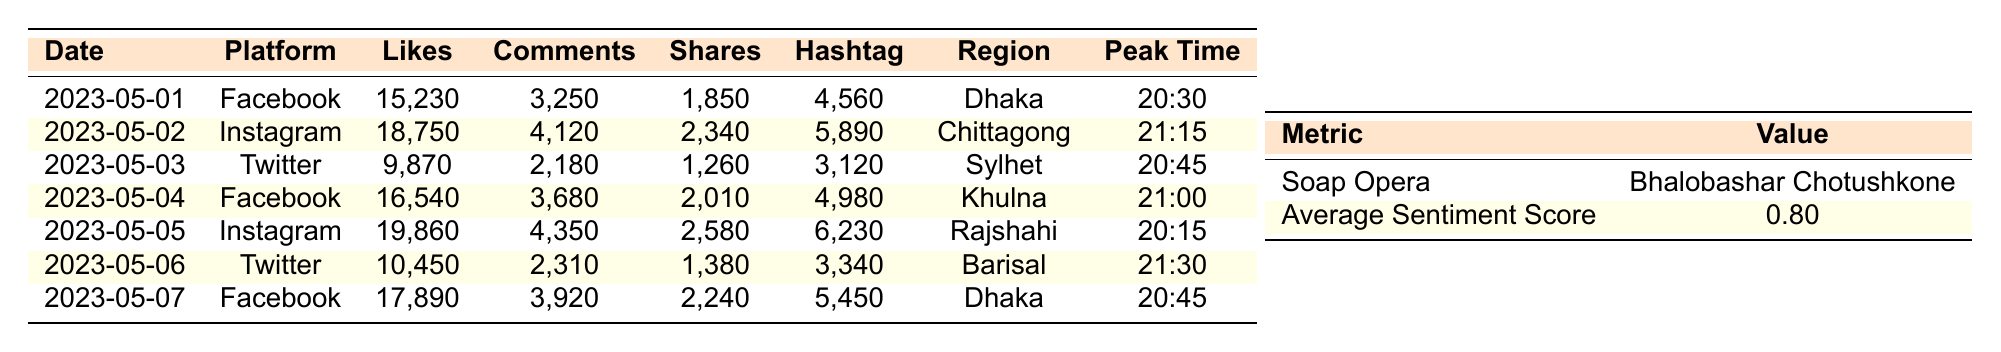What is the average number of likes across all platforms for the soap opera? To find the average number of likes, we need to sum the likes for each day and divide by the number of days. The likes are 15230, 18750, 9870, 16540, 19860, 10450, 17890. Total likes = 15230 + 18750 + 9870 + 16540 + 19860 + 10450 + 17890 = 113,570. There are 7 days, so the average is 113,570 / 7 = 16,224.29, which rounds to 16,224.
Answer: 16,224 Which platform had the highest number of comments on a single day? Looking at the comments for each platform and date, the highest number is on May 05 with 4,350 comments on Instagram.
Answer: Instagram on May 05 What was the most active region on May 02? The table indicates that on May 02, the most active region was Chittagong. This is directly stated in the table entry for that date.
Answer: Chittagong Is the sentiment score higher for Facebook or Instagram on May 05? On May 05, Facebook has a sentiment score of 0.81, while Instagram has a sentiment score of 0.85. Since 0.85 is greater than 0.81, we conclude that the sentiment score is higher for Instagram.
Answer: Instagram What is the total number of shares across all platforms for the soap opera? We need to sum the shares for each day: 1850 + 2340 + 1260 + 2010 + 2580 + 1380 + 2240 = 12,620.
Answer: 12,620 Did any platform consistently have the highest engagement in terms of likes over the week? After checking each date's likes, Instagram has the highest likes on May 02 and May 05, Facebook had higher likes on May 01, May 04, and May 07, while Twitter had the least likes on all dates. Therefore, there is no single platform with consistently the highest engagement throughout the entire week.
Answer: No On which date did the soap opera have its peak engagement time at 21:30? When we check the peak engagement times for each date, only May 06 shows a peak engagement time of 21:30.
Answer: May 06 What was the difference in hashtag mentions between the highest and lowest day? The highest number of hashtag mentions is 6,230 on May 05 and the lowest is 3,120 on May 03. The difference is 6,230 - 3,120 = 3,110.
Answer: 3,110 Which day had a higher sentiment score, May 01 or May 03? The sentiment score on May 01 is 0.78, and on May 03, it is 0.75. Thus, May 01 had a higher sentiment score than May 03.
Answer: May 01 What is the average number of shares for Twitter over the analyzed days? For Twitter, the shares are 1260 (May 03), 1380 (May 06), and 2,340 (May 02). The average is (1260 + 1380 + 2340) / 3 = 1660.
Answer: 1660 